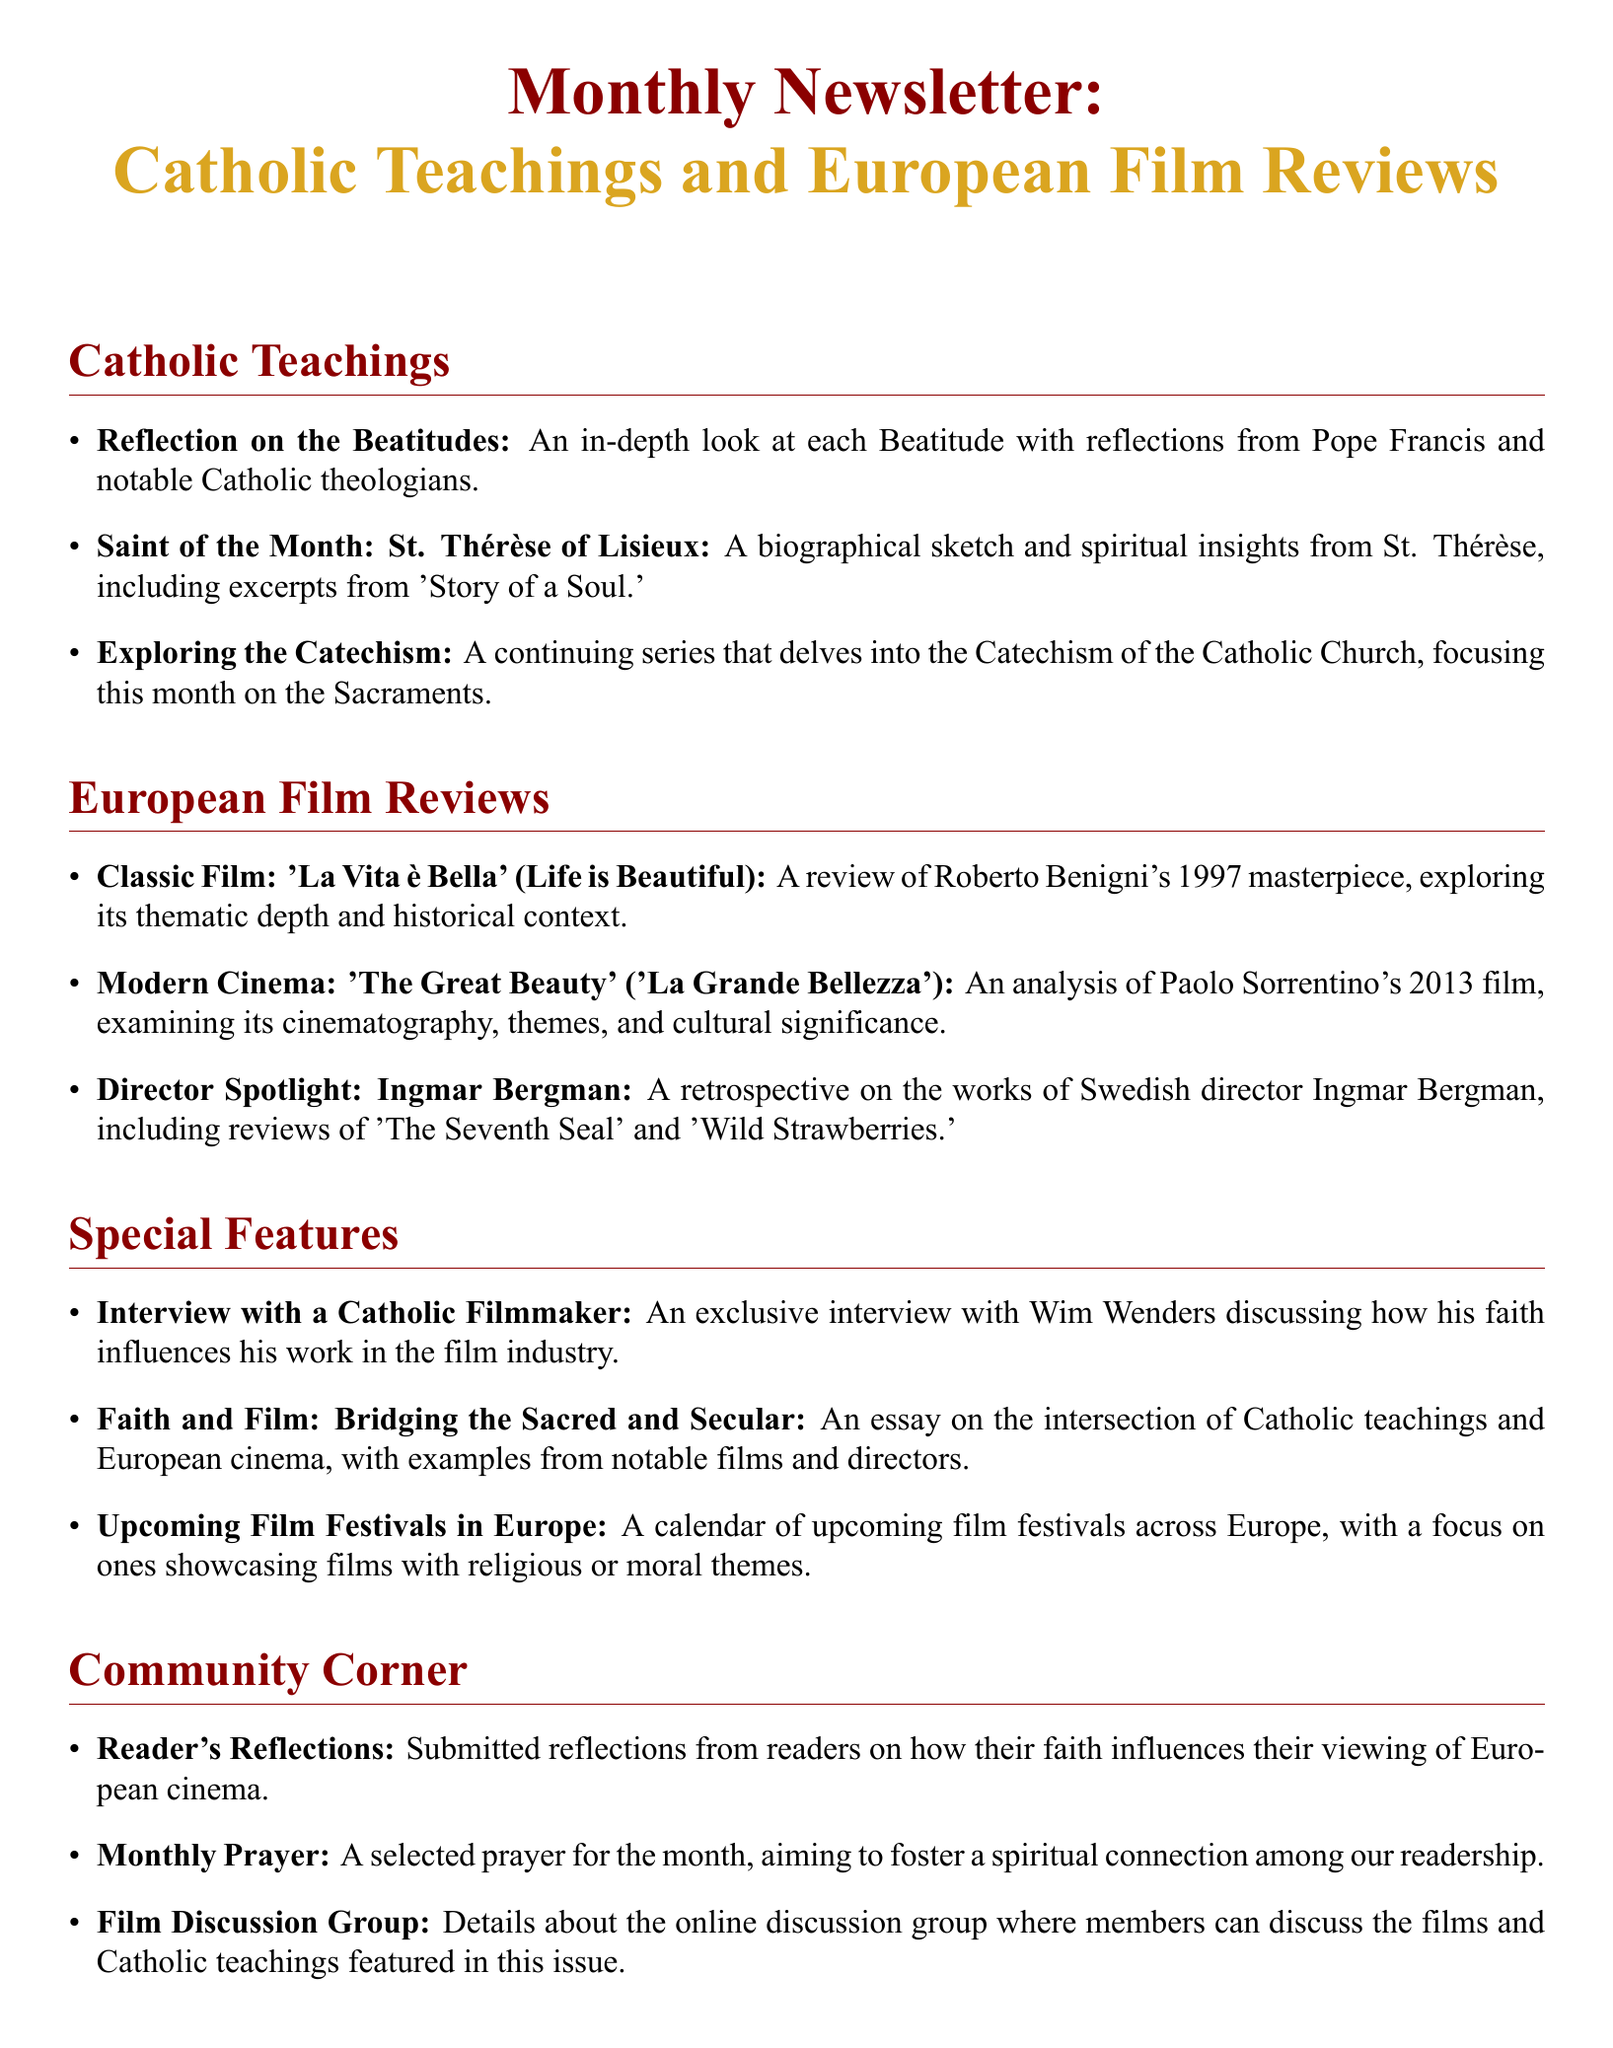What are the Beatitudes? The document includes an item titled "Reflection on the Beatitudes," suggesting it provides insights about this aspect of Catholic teaching.
Answer: The Beatitudes Who is the Saint of the Month? The newsletter features a special section on the saint of the month, specifically focusing on St. Thérèse of Lisieux.
Answer: St. Thérèse of Lisieux What is the title of the classic film reviewed this month? The European Film Reviews section lists "La Vita è Bella" as the classic film reviewed, indicating its relevance in the newsletter.
Answer: La Vita è Bella What year was "The Great Beauty" released? The document mentions that "The Great Beauty" was released in 2013, providing a clear timeframe for the film's release.
Answer: 2013 Who is the filmmaker interviewed in the special features? The newsletter highlights an exclusive interview with Wim Wenders, indicating his significance in relation to the content.
Answer: Wim Wenders What is the main theme of the essay titled "Faith and Film"? This essay discusses the relationship between Catholic teachings and European cinema, providing a thematic connection for the readers.
Answer: The intersection of Catholic teachings and European cinema How often does the Film Discussion Group meet? The document implies the frequency of discussions but doesn't specify; however, it indicates ongoing engagement with the material.
Answer: Monthly What is the selected prayer for this month intended to do? The newsletter states that the prayer aims to foster a spiritual connection, suggesting its purpose to enhance faith among readers.
Answer: Foster a spiritual connection Which film director is featured in the Director Spotlight? The section on director spotlight specifically mentions Ingmar Bergman, indicating his importance in the film review context.
Answer: Ingmar Bergman What is the purpose of the Community Corner? This section encompasses reader engagement elements such as reflections and prayers, indicating its community-building aspect.
Answer: Community engagement 